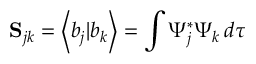<formula> <loc_0><loc_0><loc_500><loc_500>S _ { j k } = \left \langle b _ { j } | b _ { k } \right \rangle = \int \Psi _ { j } ^ { * } \Psi _ { k } \, d \tau</formula> 